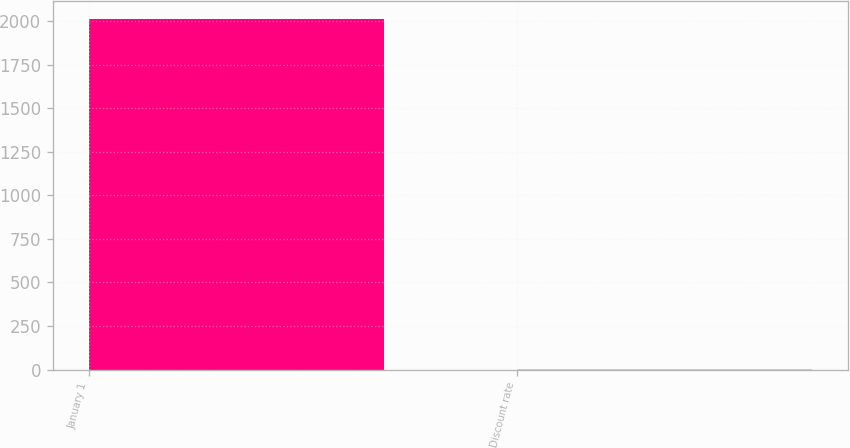<chart> <loc_0><loc_0><loc_500><loc_500><bar_chart><fcel>January 1<fcel>Discount rate<nl><fcel>2013<fcel>3.45<nl></chart> 